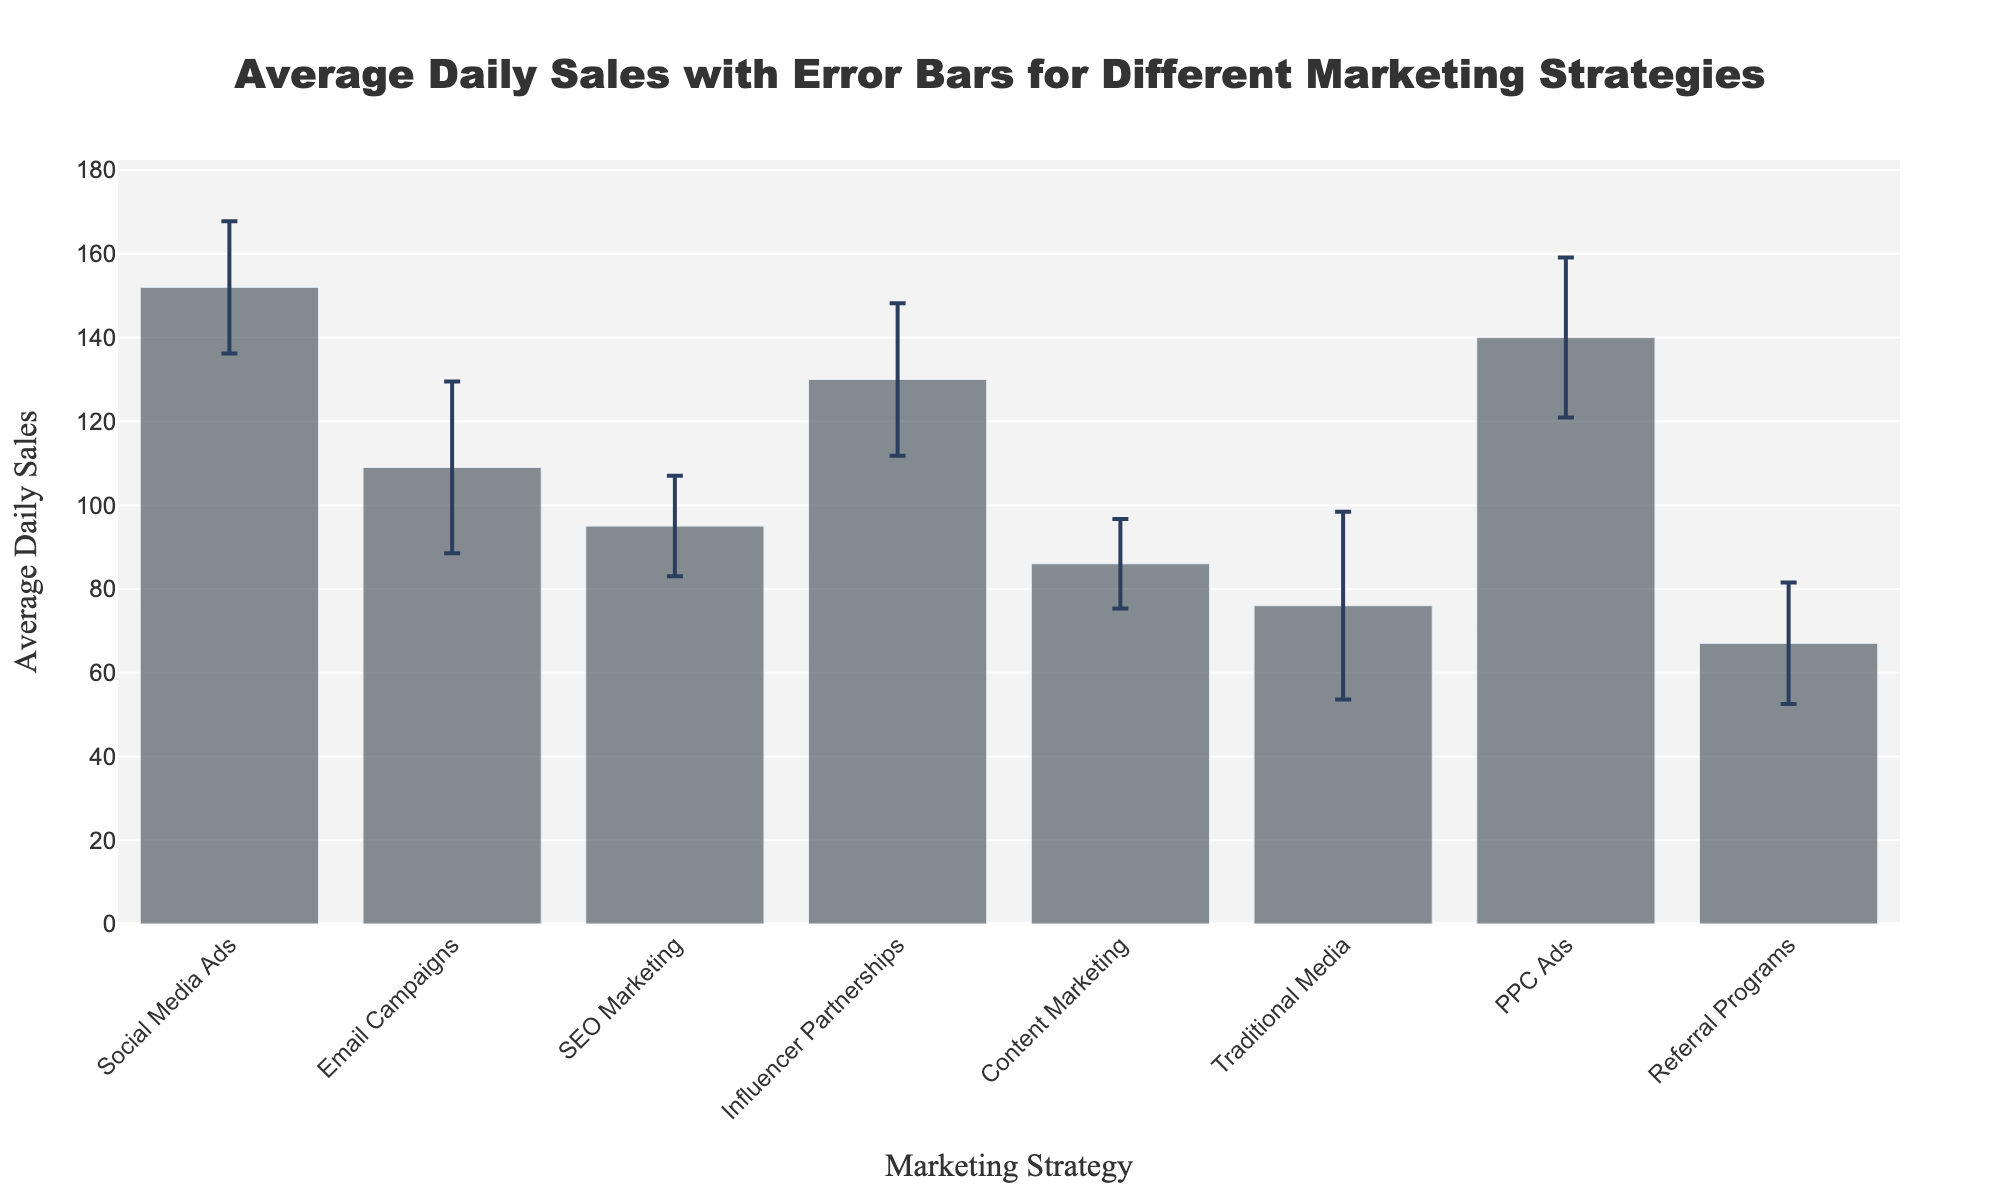What's the title of the figure? The figure title is prominently displayed at the top of the chart.
Answer: Average Daily Sales with Error Bars for Different Marketing Strategies How many marketing strategies are plotted in the figure? Count the number of bars representing different marketing strategies in the chart.
Answer: 8 Which marketing strategy has the highest average daily sales? Identify the bar that reaches the highest point on the y-axis.
Answer: Social Media Ads What is the average daily sales for Content Marketing? Locate the bar for Content Marketing and read the value on the y-axis.
Answer: 86 Which marketing strategy has the largest standard deviation in daily sales? Look for the marketing strategy with the largest error bar (tallest vertical line above and below the bar).
Answer: Traditional Media How much higher are the average daily sales of Social Media Ads compared to Content Marketing? Subtract the average daily sales of Content Marketing from those of Social Media Ads: 152 - 86.
Answer: 66 What is the total combined average daily sales of Email Campaigns and SEO Marketing? Add the average daily sales of Email Campaigns and SEO Marketing: 109 + 95.
Answer: 204 Which marketing strategy has the smallest standard deviation in daily sales? Identify the marketing strategy with the shortest error bar (smallest vertical line above and below the bar).
Answer: Content Marketing Rank the marketing strategies from highest to lowest average daily sales. Order the marketing strategies by the height of their bars from tallest to shortest: Social Media Ads, PPC Ads, Influencer Partnerships, Email Campaigns, SEO Marketing, Content Marketing, Traditional Media, Referral Programs.
Answer: Social Media Ads, PPC Ads, Influencer Partnerships, Email Campaigns, SEO Marketing, Content Marketing, Traditional Media, Referral Programs Which two marketing strategies have average daily sales closest to each other? Compare the heights of all bars and identify the two bars that are nearest in value.
Answer: Influencer Partnerships and PPC Ads 